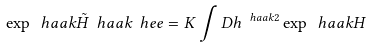Convert formula to latex. <formula><loc_0><loc_0><loc_500><loc_500>\exp \ h a a k { \tilde { H } \ h a a k { \ h e e } } = K \int D h ^ { \ h a a k { 2 } } \exp \ h a a k { H }</formula> 